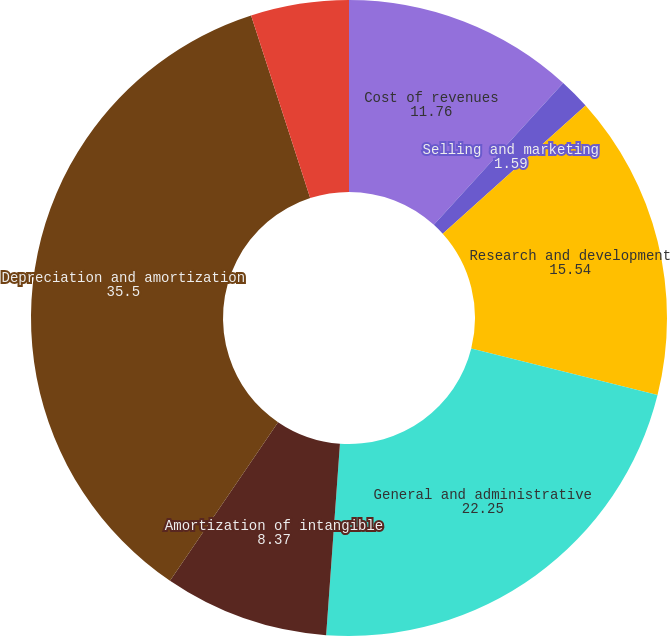Convert chart. <chart><loc_0><loc_0><loc_500><loc_500><pie_chart><fcel>Cost of revenues<fcel>Selling and marketing<fcel>Research and development<fcel>General and administrative<fcel>Amortization of intangible<fcel>Depreciation and amortization<fcel>Total operating expenses<nl><fcel>11.76%<fcel>1.59%<fcel>15.54%<fcel>22.25%<fcel>8.37%<fcel>35.5%<fcel>4.98%<nl></chart> 